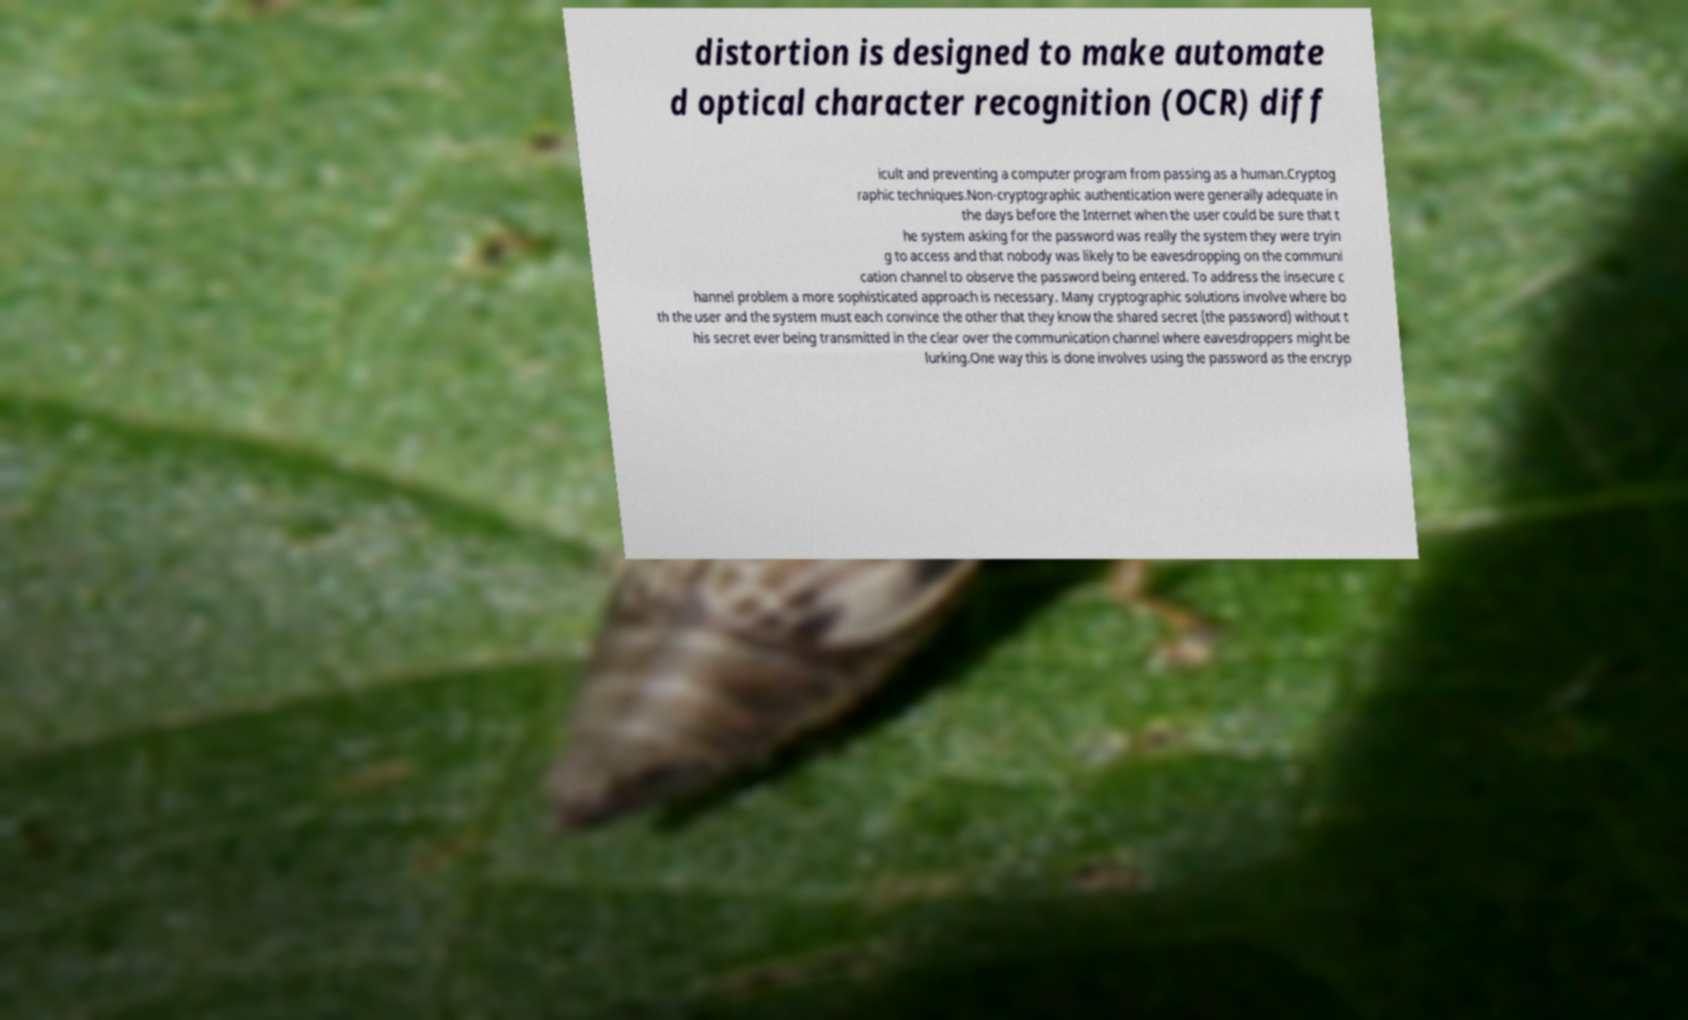Can you read and provide the text displayed in the image?This photo seems to have some interesting text. Can you extract and type it out for me? distortion is designed to make automate d optical character recognition (OCR) diff icult and preventing a computer program from passing as a human.Cryptog raphic techniques.Non-cryptographic authentication were generally adequate in the days before the Internet when the user could be sure that t he system asking for the password was really the system they were tryin g to access and that nobody was likely to be eavesdropping on the communi cation channel to observe the password being entered. To address the insecure c hannel problem a more sophisticated approach is necessary. Many cryptographic solutions involve where bo th the user and the system must each convince the other that they know the shared secret (the password) without t his secret ever being transmitted in the clear over the communication channel where eavesdroppers might be lurking.One way this is done involves using the password as the encryp 